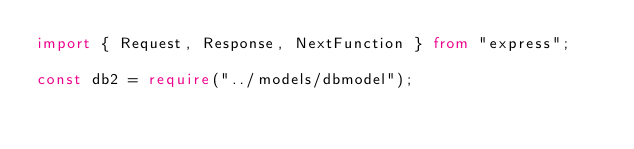<code> <loc_0><loc_0><loc_500><loc_500><_TypeScript_>import { Request, Response, NextFunction } from "express";

const db2 = require("../models/dbmodel");
</code> 